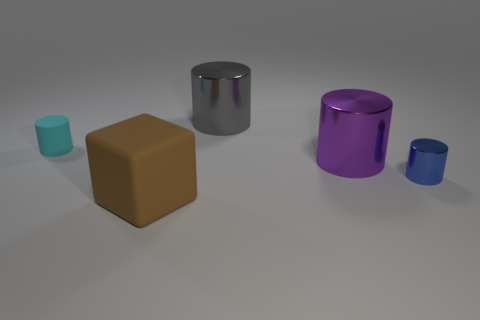Is the number of tiny green things less than the number of tiny rubber cylinders?
Keep it short and to the point. Yes. There is a small blue metal cylinder; are there any big objects in front of it?
Your response must be concise. Yes. There is a big thing that is right of the brown thing and in front of the gray metal cylinder; what shape is it?
Your response must be concise. Cylinder. Are there any other large things of the same shape as the purple object?
Offer a very short reply. Yes. Is the size of the metal object that is behind the tiny cyan matte object the same as the matte thing in front of the purple cylinder?
Ensure brevity in your answer.  Yes. Are there more purple cylinders than big metallic cylinders?
Provide a succinct answer. No. What number of blue things have the same material as the gray cylinder?
Your answer should be compact. 1. Is the blue object the same shape as the purple metal object?
Provide a succinct answer. Yes. There is a purple shiny cylinder behind the rubber thing that is on the right side of the matte thing that is to the left of the brown cube; what is its size?
Your response must be concise. Large. Are there any big brown things that are on the right side of the small thing right of the cyan rubber cylinder?
Your answer should be very brief. No. 